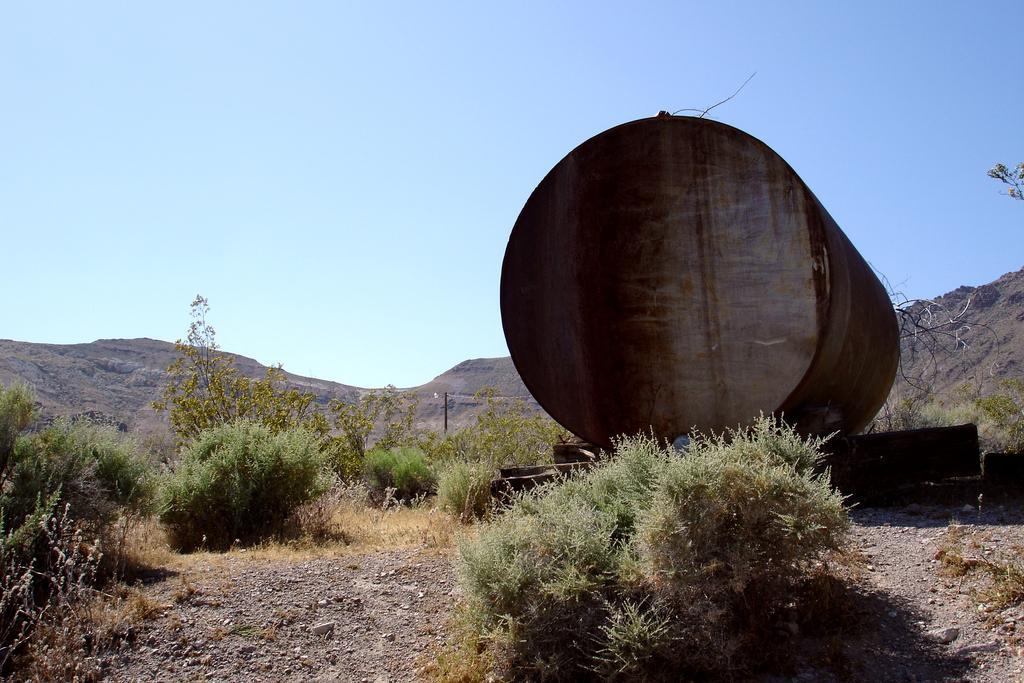How would you summarize this image in a sentence or two? In this picture I can observe a container on the right side. There are some plants on the ground. In the background there are hills and sky. 